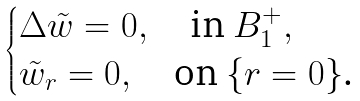<formula> <loc_0><loc_0><loc_500><loc_500>\begin{cases} \Delta \tilde { w } = 0 , \quad \text {in $B_{1}^{+},$} \\ \tilde { w } _ { r } = 0 , \quad \text {on $\{r=0\}$.} \end{cases}</formula> 